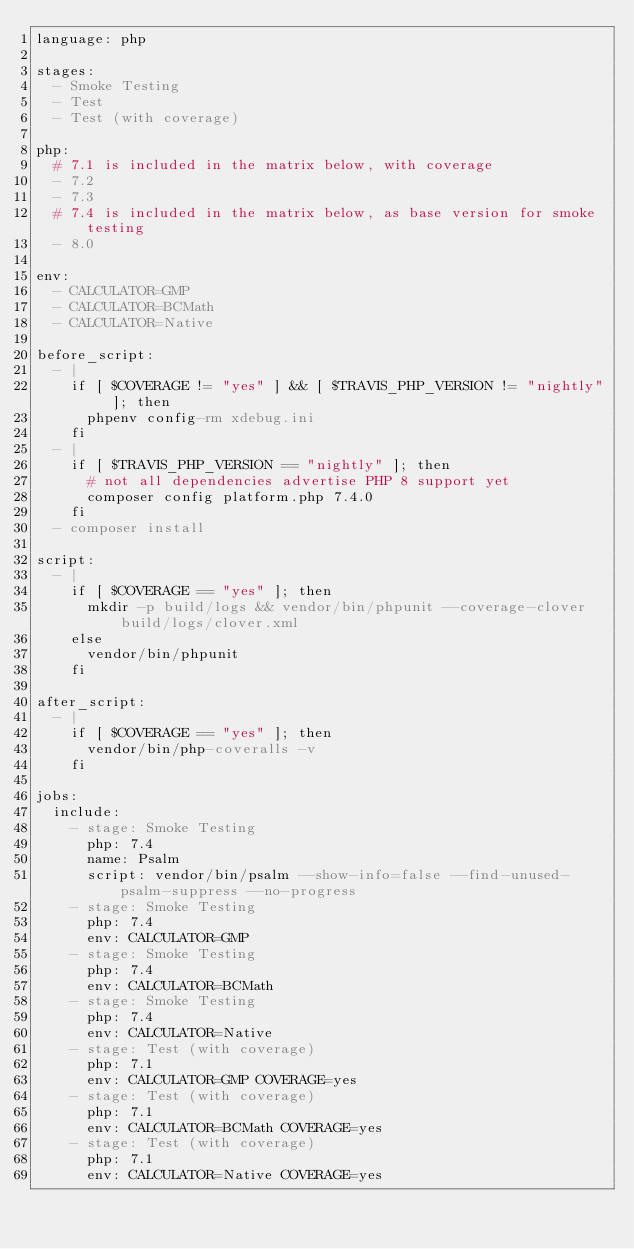Convert code to text. <code><loc_0><loc_0><loc_500><loc_500><_YAML_>language: php

stages:
  - Smoke Testing
  - Test
  - Test (with coverage)

php:
  # 7.1 is included in the matrix below, with coverage
  - 7.2
  - 7.3
  # 7.4 is included in the matrix below, as base version for smoke testing
  - 8.0

env:
  - CALCULATOR=GMP
  - CALCULATOR=BCMath
  - CALCULATOR=Native

before_script:
  - |
    if [ $COVERAGE != "yes" ] && [ $TRAVIS_PHP_VERSION != "nightly" ]; then
      phpenv config-rm xdebug.ini
    fi
  - |
    if [ $TRAVIS_PHP_VERSION == "nightly" ]; then
      # not all dependencies advertise PHP 8 support yet
      composer config platform.php 7.4.0
    fi
  - composer install

script:
  - |
    if [ $COVERAGE == "yes" ]; then
      mkdir -p build/logs && vendor/bin/phpunit --coverage-clover build/logs/clover.xml
    else
      vendor/bin/phpunit
    fi

after_script:
  - |
    if [ $COVERAGE == "yes" ]; then
      vendor/bin/php-coveralls -v
    fi

jobs:
  include:
    - stage: Smoke Testing
      php: 7.4
      name: Psalm
      script: vendor/bin/psalm --show-info=false --find-unused-psalm-suppress --no-progress
    - stage: Smoke Testing
      php: 7.4
      env: CALCULATOR=GMP
    - stage: Smoke Testing
      php: 7.4
      env: CALCULATOR=BCMath
    - stage: Smoke Testing
      php: 7.4
      env: CALCULATOR=Native
    - stage: Test (with coverage)
      php: 7.1
      env: CALCULATOR=GMP COVERAGE=yes
    - stage: Test (with coverage)
      php: 7.1
      env: CALCULATOR=BCMath COVERAGE=yes
    - stage: Test (with coverage)
      php: 7.1
      env: CALCULATOR=Native COVERAGE=yes
</code> 